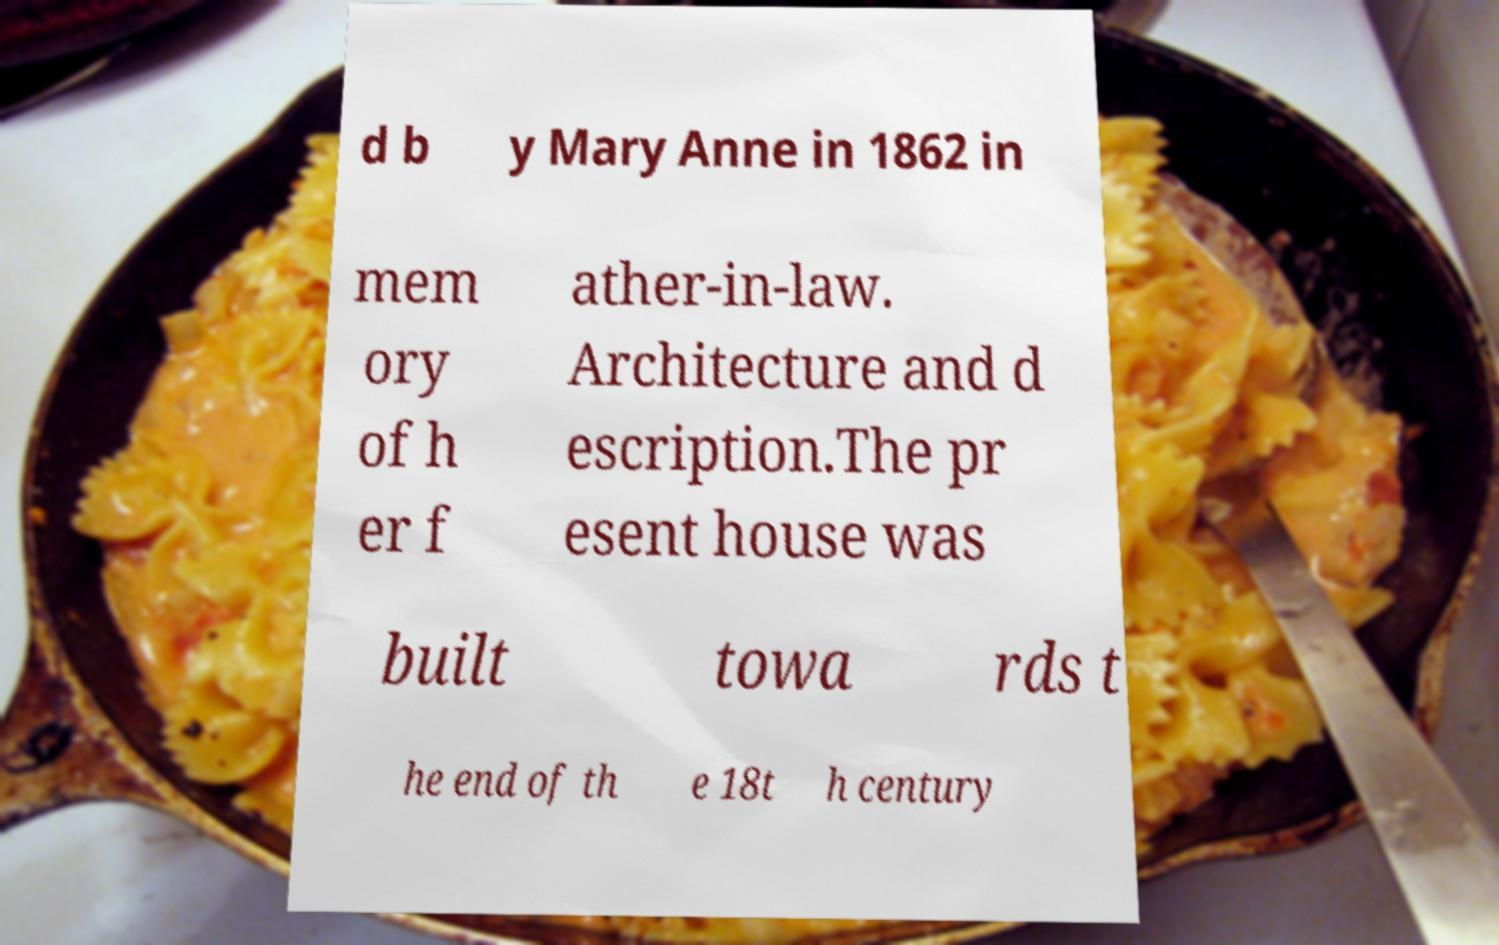Please read and relay the text visible in this image. What does it say? d b y Mary Anne in 1862 in mem ory of h er f ather-in-law. Architecture and d escription.The pr esent house was built towa rds t he end of th e 18t h century 